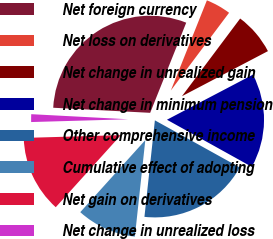<chart> <loc_0><loc_0><loc_500><loc_500><pie_chart><fcel>Net foreign currency<fcel>Net loss on derivatives<fcel>Net change in unrealized gain<fcel>Net change in minimum pension<fcel>Other comprehensive income<fcel>Cumulative effect of adopting<fcel>Net gain on derivatives<fcel>Net change in unrealized loss<nl><fcel>30.22%<fcel>4.18%<fcel>7.08%<fcel>15.75%<fcel>18.65%<fcel>9.97%<fcel>12.86%<fcel>1.29%<nl></chart> 